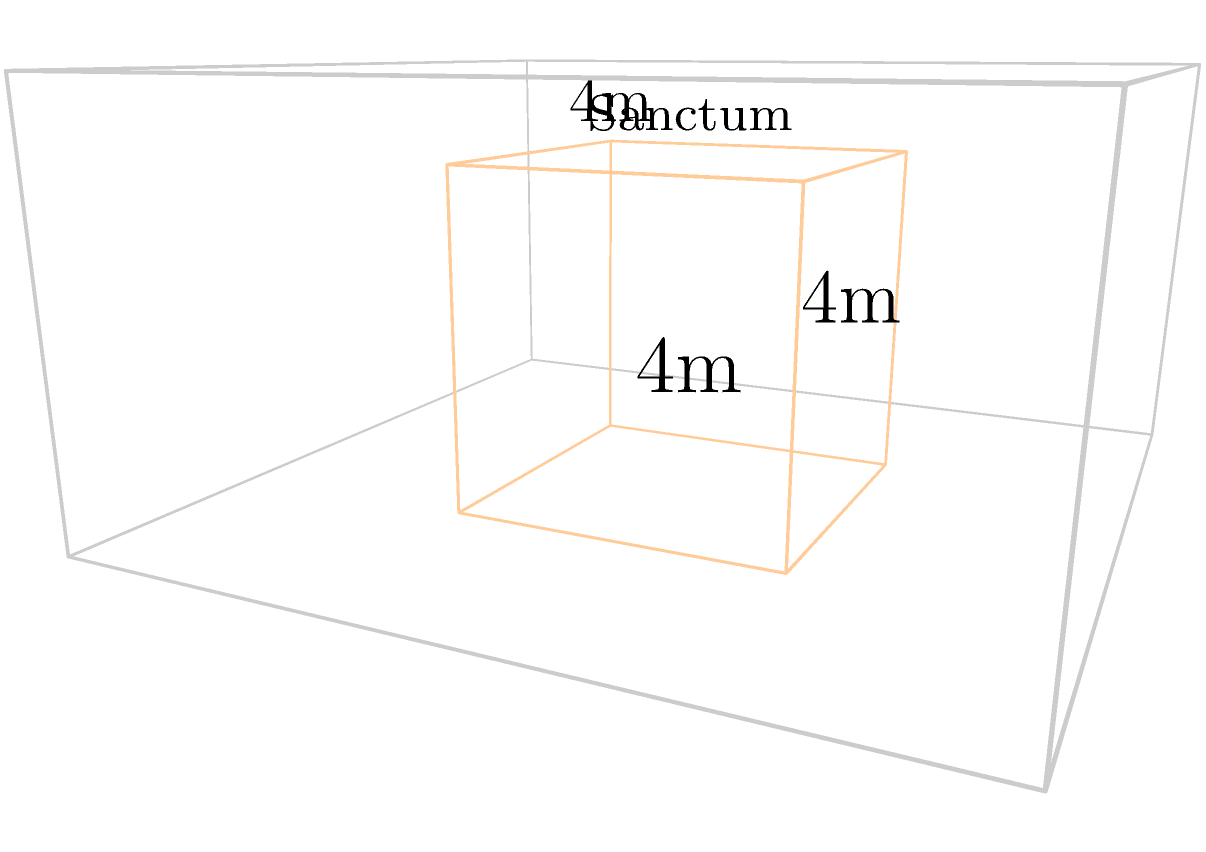In a Vaishnava temple complex, there is a cubic sanctum where the deity resides. The sanctum measures 4 meters on each side. As a devotee responsible for the temple's maintenance, you need to calculate the total surface area of the sanctum to determine the amount of special purifying paint required for its walls, ceiling, and floor. What is the total surface area of the cubic sanctum in square meters? To calculate the surface area of a cube, we need to follow these steps:

1. Recall the formula for the surface area of a cube:
   $$SA = 6s^2$$
   Where $SA$ is the surface area and $s$ is the length of one side of the cube.

2. In this case, we are given that each side of the cubic sanctum measures 4 meters.
   So, $s = 4$ meters.

3. Let's substitute this value into our formula:
   $$SA = 6 \cdot (4m)^2$$

4. Simplify the expression:
   $$SA = 6 \cdot 16m^2 = 96m^2$$

5. Therefore, the total surface area of the cubic sanctum is 96 square meters.

This calculation includes all six faces of the cube: the four walls, the ceiling, and the floor. As a devotee, you now know the exact area that needs to be covered with the special purifying paint to maintain the sanctity of the deity's abode.
Answer: 96 $m^2$ 